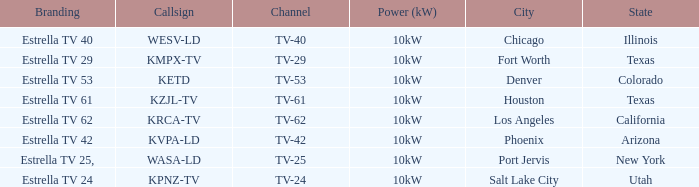Write the full table. {'header': ['Branding', 'Callsign', 'Channel', 'Power (kW)', 'City', 'State'], 'rows': [['Estrella TV 40', 'WESV-LD', 'TV-40', '10kW', 'Chicago', 'Illinois'], ['Estrella TV 29', 'KMPX-TV', 'TV-29', '10kW', 'Fort Worth', 'Texas'], ['Estrella TV 53', 'KETD', 'TV-53', '10kW', 'Denver', 'Colorado'], ['Estrella TV 61', 'KZJL-TV', 'TV-61', '10kW', 'Houston', 'Texas'], ['Estrella TV 62', 'KRCA-TV', 'TV-62', '10kW', 'Los Angeles', 'California'], ['Estrella TV 42', 'KVPA-LD', 'TV-42', '10kW', 'Phoenix', 'Arizona'], ['Estrella TV 25,', 'WASA-LD', 'TV-25', '10kW', 'Port Jervis', 'New York'], ['Estrella TV 24', 'KPNZ-TV', 'TV-24', '10kW', 'Salt Lake City', 'Utah']]} Which area did estrella tv 62 provide coverage for? Los Angeles, California. 